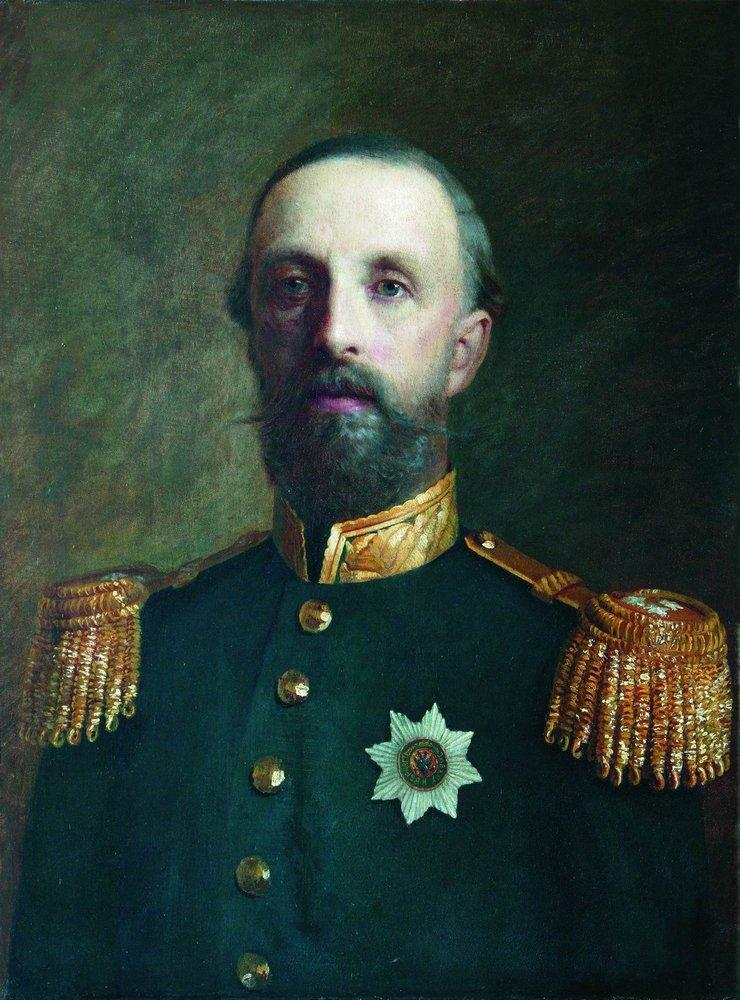Tell me a story about who this man might be. Imagine a man named General Alexander, a revered figure in his country's military history. Born into a family with a rich tradition of service, Alexander quickly rose through the ranks due to his strategic brilliance and unwavering valor. His career was marked by numerous victories in crucial battles, earning him the respect and admiration of his peers and subordinates alike. The white star on his chest was awarded to him after a decisive battle where he led his troops to victory against overwhelming odds. The portrait captures him in his later years, reflecting not only his professional achievements but also the weight of his many years of service and the responsibilities that came with them. The somber brown background symbolizes the turbulent times he lived through, while his proud bearing in the portrait hints at the enduring impact he had on his country's history. 